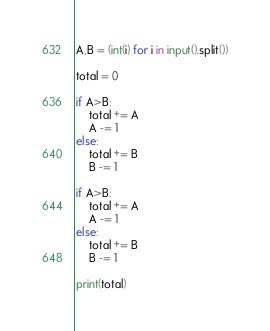<code> <loc_0><loc_0><loc_500><loc_500><_Python_>A,B = (int(i) for i in input().split())

total = 0

if A>B:
    total += A
    A -= 1
else:
    total += B
    B -= 1
    
if A>B:
    total += A
    A -= 1
else:
    total += B
    B -= 1

print(total)</code> 